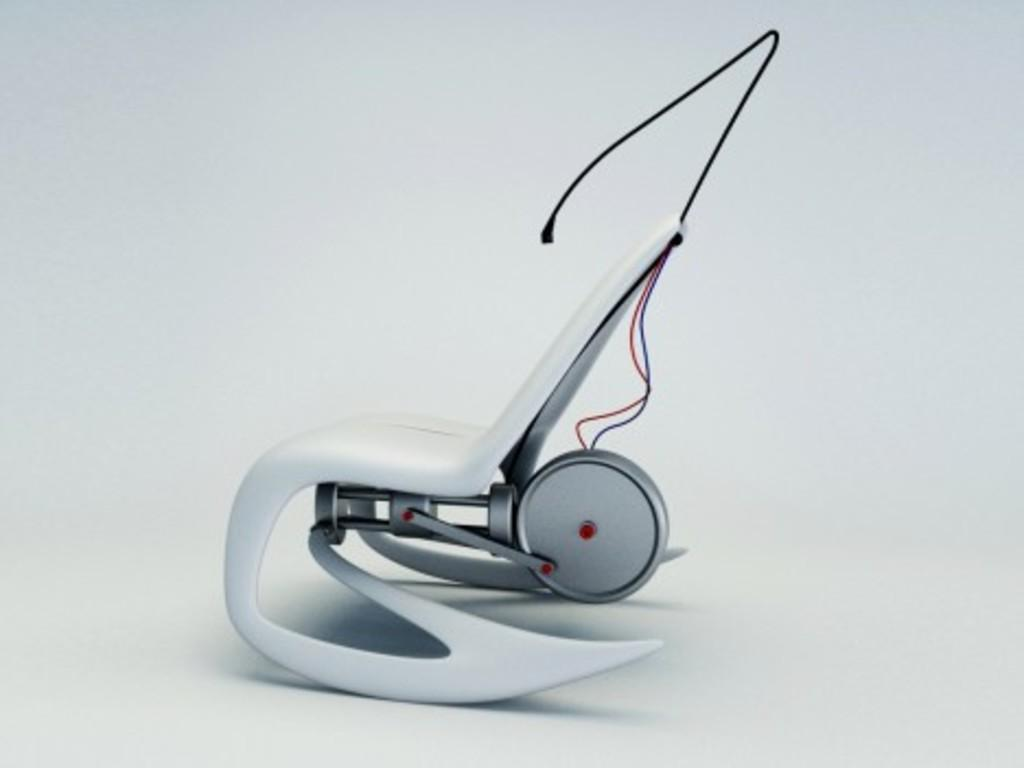What is the main object in the image? There is an object in the image that appears to be a chair. Is there anything connected to the chair? Yes, there is a machine attached to the chair. What color is the background of the image? The background of the image is white. What kind of trouble does the chair's daughter get into in the image? There is no mention of a chair's daughter in the image, and therefore no such trouble can be observed. 